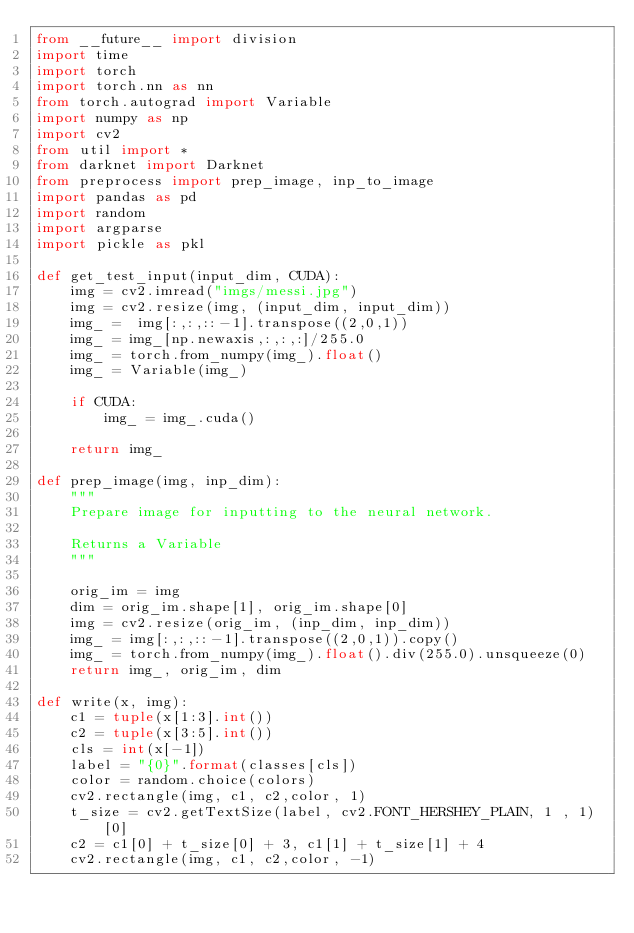Convert code to text. <code><loc_0><loc_0><loc_500><loc_500><_Python_>from __future__ import division
import time
import torch 
import torch.nn as nn
from torch.autograd import Variable
import numpy as np
import cv2 
from util import *
from darknet import Darknet
from preprocess import prep_image, inp_to_image
import pandas as pd
import random 
import argparse
import pickle as pkl

def get_test_input(input_dim, CUDA):
    img = cv2.imread("imgs/messi.jpg")
    img = cv2.resize(img, (input_dim, input_dim)) 
    img_ =  img[:,:,::-1].transpose((2,0,1))
    img_ = img_[np.newaxis,:,:,:]/255.0
    img_ = torch.from_numpy(img_).float()
    img_ = Variable(img_)
    
    if CUDA:
        img_ = img_.cuda()
    
    return img_

def prep_image(img, inp_dim):
    """
    Prepare image for inputting to the neural network. 
    
    Returns a Variable 
    """

    orig_im = img
    dim = orig_im.shape[1], orig_im.shape[0]
    img = cv2.resize(orig_im, (inp_dim, inp_dim))
    img_ = img[:,:,::-1].transpose((2,0,1)).copy()
    img_ = torch.from_numpy(img_).float().div(255.0).unsqueeze(0)
    return img_, orig_im, dim

def write(x, img):
    c1 = tuple(x[1:3].int())
    c2 = tuple(x[3:5].int())
    cls = int(x[-1])
    label = "{0}".format(classes[cls])
    color = random.choice(colors)
    cv2.rectangle(img, c1, c2,color, 1)
    t_size = cv2.getTextSize(label, cv2.FONT_HERSHEY_PLAIN, 1 , 1)[0]
    c2 = c1[0] + t_size[0] + 3, c1[1] + t_size[1] + 4
    cv2.rectangle(img, c1, c2,color, -1)</code> 